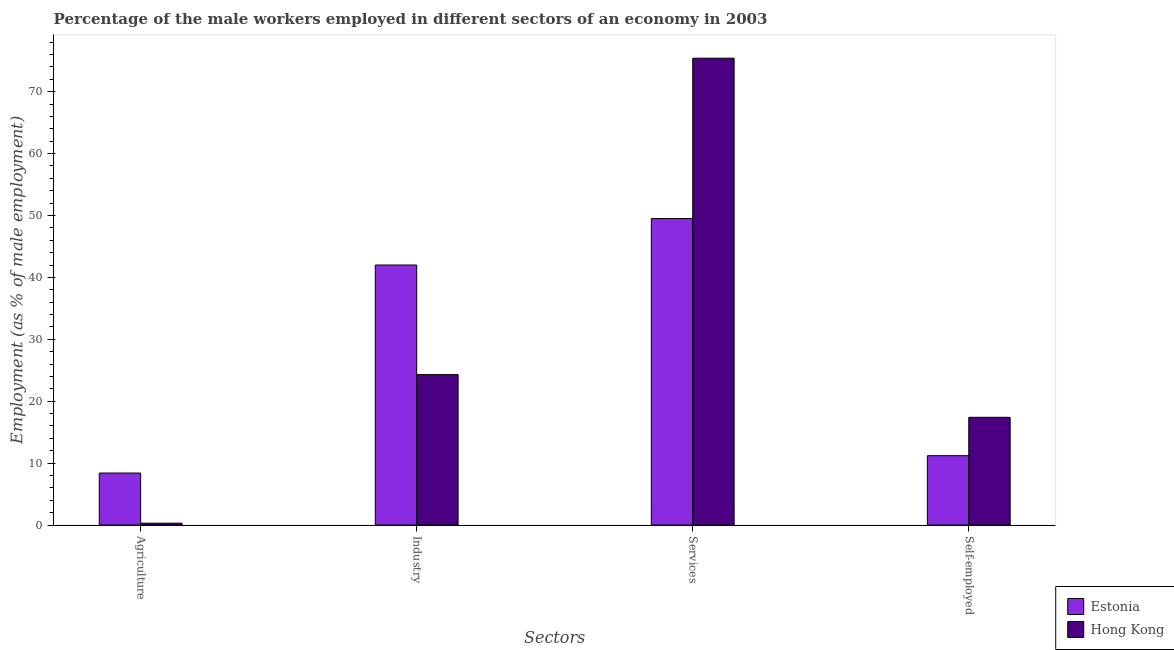How many different coloured bars are there?
Provide a succinct answer. 2. Are the number of bars on each tick of the X-axis equal?
Provide a succinct answer. Yes. How many bars are there on the 1st tick from the left?
Your answer should be compact. 2. How many bars are there on the 4th tick from the right?
Your answer should be compact. 2. What is the label of the 3rd group of bars from the left?
Provide a short and direct response. Services. What is the percentage of male workers in agriculture in Estonia?
Your answer should be very brief. 8.4. Across all countries, what is the maximum percentage of male workers in services?
Your answer should be very brief. 75.4. Across all countries, what is the minimum percentage of male workers in services?
Your response must be concise. 49.5. In which country was the percentage of male workers in agriculture maximum?
Keep it short and to the point. Estonia. In which country was the percentage of male workers in agriculture minimum?
Give a very brief answer. Hong Kong. What is the total percentage of male workers in industry in the graph?
Offer a terse response. 66.3. What is the difference between the percentage of male workers in agriculture in Estonia and that in Hong Kong?
Your response must be concise. 8.1. What is the difference between the percentage of self employed male workers in Estonia and the percentage of male workers in agriculture in Hong Kong?
Offer a very short reply. 10.9. What is the average percentage of self employed male workers per country?
Offer a terse response. 14.3. What is the difference between the percentage of male workers in services and percentage of self employed male workers in Hong Kong?
Provide a succinct answer. 58. In how many countries, is the percentage of male workers in services greater than 58 %?
Provide a succinct answer. 1. What is the ratio of the percentage of male workers in services in Hong Kong to that in Estonia?
Provide a succinct answer. 1.52. Is the difference between the percentage of male workers in services in Estonia and Hong Kong greater than the difference between the percentage of self employed male workers in Estonia and Hong Kong?
Offer a very short reply. No. What is the difference between the highest and the second highest percentage of male workers in agriculture?
Keep it short and to the point. 8.1. What is the difference between the highest and the lowest percentage of male workers in agriculture?
Your response must be concise. 8.1. In how many countries, is the percentage of self employed male workers greater than the average percentage of self employed male workers taken over all countries?
Make the answer very short. 1. What does the 1st bar from the left in Agriculture represents?
Make the answer very short. Estonia. What does the 2nd bar from the right in Services represents?
Provide a succinct answer. Estonia. How many bars are there?
Keep it short and to the point. 8. How many countries are there in the graph?
Make the answer very short. 2. What is the difference between two consecutive major ticks on the Y-axis?
Ensure brevity in your answer.  10. Are the values on the major ticks of Y-axis written in scientific E-notation?
Your response must be concise. No. Where does the legend appear in the graph?
Provide a short and direct response. Bottom right. What is the title of the graph?
Offer a terse response. Percentage of the male workers employed in different sectors of an economy in 2003. What is the label or title of the X-axis?
Provide a short and direct response. Sectors. What is the label or title of the Y-axis?
Provide a succinct answer. Employment (as % of male employment). What is the Employment (as % of male employment) in Estonia in Agriculture?
Offer a very short reply. 8.4. What is the Employment (as % of male employment) of Hong Kong in Agriculture?
Your answer should be very brief. 0.3. What is the Employment (as % of male employment) of Estonia in Industry?
Make the answer very short. 42. What is the Employment (as % of male employment) of Hong Kong in Industry?
Keep it short and to the point. 24.3. What is the Employment (as % of male employment) of Estonia in Services?
Give a very brief answer. 49.5. What is the Employment (as % of male employment) of Hong Kong in Services?
Provide a short and direct response. 75.4. What is the Employment (as % of male employment) in Estonia in Self-employed?
Provide a succinct answer. 11.2. What is the Employment (as % of male employment) of Hong Kong in Self-employed?
Provide a short and direct response. 17.4. Across all Sectors, what is the maximum Employment (as % of male employment) in Estonia?
Your answer should be compact. 49.5. Across all Sectors, what is the maximum Employment (as % of male employment) in Hong Kong?
Make the answer very short. 75.4. Across all Sectors, what is the minimum Employment (as % of male employment) of Estonia?
Your response must be concise. 8.4. Across all Sectors, what is the minimum Employment (as % of male employment) in Hong Kong?
Give a very brief answer. 0.3. What is the total Employment (as % of male employment) of Estonia in the graph?
Keep it short and to the point. 111.1. What is the total Employment (as % of male employment) of Hong Kong in the graph?
Your response must be concise. 117.4. What is the difference between the Employment (as % of male employment) of Estonia in Agriculture and that in Industry?
Give a very brief answer. -33.6. What is the difference between the Employment (as % of male employment) in Hong Kong in Agriculture and that in Industry?
Offer a terse response. -24. What is the difference between the Employment (as % of male employment) in Estonia in Agriculture and that in Services?
Give a very brief answer. -41.1. What is the difference between the Employment (as % of male employment) of Hong Kong in Agriculture and that in Services?
Your answer should be very brief. -75.1. What is the difference between the Employment (as % of male employment) in Estonia in Agriculture and that in Self-employed?
Your response must be concise. -2.8. What is the difference between the Employment (as % of male employment) of Hong Kong in Agriculture and that in Self-employed?
Offer a very short reply. -17.1. What is the difference between the Employment (as % of male employment) of Hong Kong in Industry and that in Services?
Give a very brief answer. -51.1. What is the difference between the Employment (as % of male employment) in Estonia in Industry and that in Self-employed?
Your response must be concise. 30.8. What is the difference between the Employment (as % of male employment) in Estonia in Services and that in Self-employed?
Your response must be concise. 38.3. What is the difference between the Employment (as % of male employment) of Estonia in Agriculture and the Employment (as % of male employment) of Hong Kong in Industry?
Provide a succinct answer. -15.9. What is the difference between the Employment (as % of male employment) in Estonia in Agriculture and the Employment (as % of male employment) in Hong Kong in Services?
Your response must be concise. -67. What is the difference between the Employment (as % of male employment) in Estonia in Industry and the Employment (as % of male employment) in Hong Kong in Services?
Provide a short and direct response. -33.4. What is the difference between the Employment (as % of male employment) of Estonia in Industry and the Employment (as % of male employment) of Hong Kong in Self-employed?
Provide a short and direct response. 24.6. What is the difference between the Employment (as % of male employment) in Estonia in Services and the Employment (as % of male employment) in Hong Kong in Self-employed?
Ensure brevity in your answer.  32.1. What is the average Employment (as % of male employment) in Estonia per Sectors?
Provide a short and direct response. 27.77. What is the average Employment (as % of male employment) in Hong Kong per Sectors?
Offer a very short reply. 29.35. What is the difference between the Employment (as % of male employment) of Estonia and Employment (as % of male employment) of Hong Kong in Services?
Your response must be concise. -25.9. What is the ratio of the Employment (as % of male employment) in Estonia in Agriculture to that in Industry?
Your answer should be compact. 0.2. What is the ratio of the Employment (as % of male employment) of Hong Kong in Agriculture to that in Industry?
Provide a succinct answer. 0.01. What is the ratio of the Employment (as % of male employment) of Estonia in Agriculture to that in Services?
Give a very brief answer. 0.17. What is the ratio of the Employment (as % of male employment) in Hong Kong in Agriculture to that in Services?
Your answer should be compact. 0. What is the ratio of the Employment (as % of male employment) of Hong Kong in Agriculture to that in Self-employed?
Ensure brevity in your answer.  0.02. What is the ratio of the Employment (as % of male employment) in Estonia in Industry to that in Services?
Give a very brief answer. 0.85. What is the ratio of the Employment (as % of male employment) in Hong Kong in Industry to that in Services?
Your answer should be compact. 0.32. What is the ratio of the Employment (as % of male employment) of Estonia in Industry to that in Self-employed?
Make the answer very short. 3.75. What is the ratio of the Employment (as % of male employment) of Hong Kong in Industry to that in Self-employed?
Your answer should be compact. 1.4. What is the ratio of the Employment (as % of male employment) in Estonia in Services to that in Self-employed?
Your answer should be very brief. 4.42. What is the ratio of the Employment (as % of male employment) in Hong Kong in Services to that in Self-employed?
Ensure brevity in your answer.  4.33. What is the difference between the highest and the second highest Employment (as % of male employment) of Hong Kong?
Offer a very short reply. 51.1. What is the difference between the highest and the lowest Employment (as % of male employment) in Estonia?
Provide a short and direct response. 41.1. What is the difference between the highest and the lowest Employment (as % of male employment) of Hong Kong?
Your response must be concise. 75.1. 